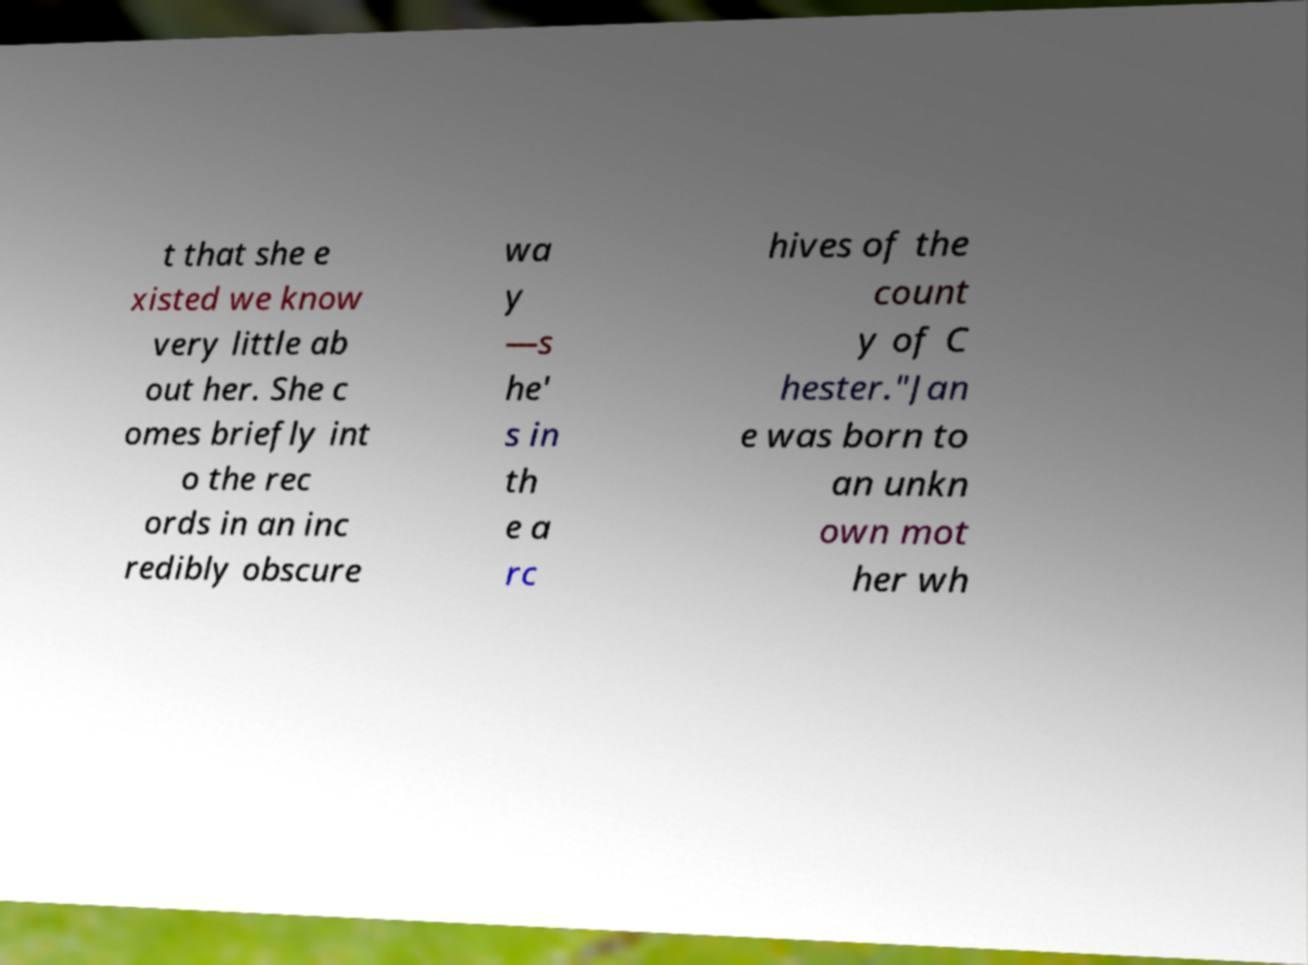Can you read and provide the text displayed in the image?This photo seems to have some interesting text. Can you extract and type it out for me? t that she e xisted we know very little ab out her. She c omes briefly int o the rec ords in an inc redibly obscure wa y —s he' s in th e a rc hives of the count y of C hester."Jan e was born to an unkn own mot her wh 